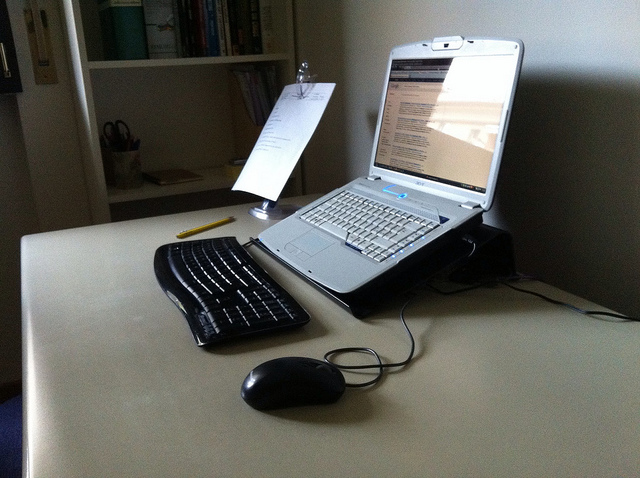<image>How many buttons are here? I don't know the exact number of buttons. It can be several or a hundred. Who is using the laptop? No one is using the laptop. Who is using the laptop? I don't know who is using the laptop. It seems like no one is using it. How many buttons are here? It is unclear how many buttons are present. It can be seen several buttons, but the exact number is unknown. 